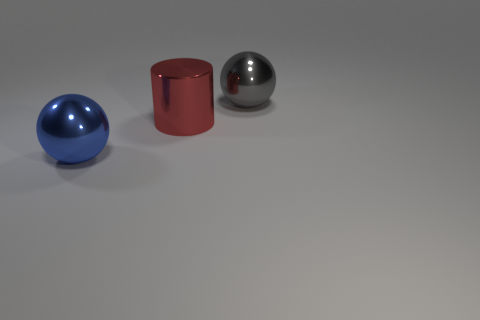Is there anything else that is the same shape as the big red metal thing?
Ensure brevity in your answer.  No. Are there fewer cylinders right of the big gray shiny object than large gray shiny cylinders?
Ensure brevity in your answer.  No. There is a metal ball on the left side of the large metallic ball to the right of the blue sphere; how big is it?
Your response must be concise. Large. What number of objects are large gray shiny spheres or large red shiny things?
Your response must be concise. 2. Are there fewer large spheres than things?
Keep it short and to the point. Yes. What number of things are red matte things or big gray metal balls to the right of the big cylinder?
Provide a succinct answer. 1. Is there another gray thing that has the same material as the gray thing?
Your answer should be compact. No. There is another ball that is the same size as the gray shiny ball; what material is it?
Give a very brief answer. Metal. There is a gray metallic object that is behind the big blue shiny thing; is its shape the same as the red thing?
Provide a short and direct response. No. What color is the big cylinder that is made of the same material as the blue thing?
Your answer should be very brief. Red. 